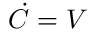<formula> <loc_0><loc_0><loc_500><loc_500>\dot { C } = V</formula> 